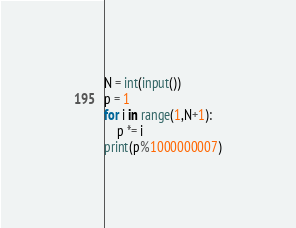Convert code to text. <code><loc_0><loc_0><loc_500><loc_500><_Python_>N = int(input())
p = 1
for i in range(1,N+1):
    p *= i
print(p%1000000007)</code> 